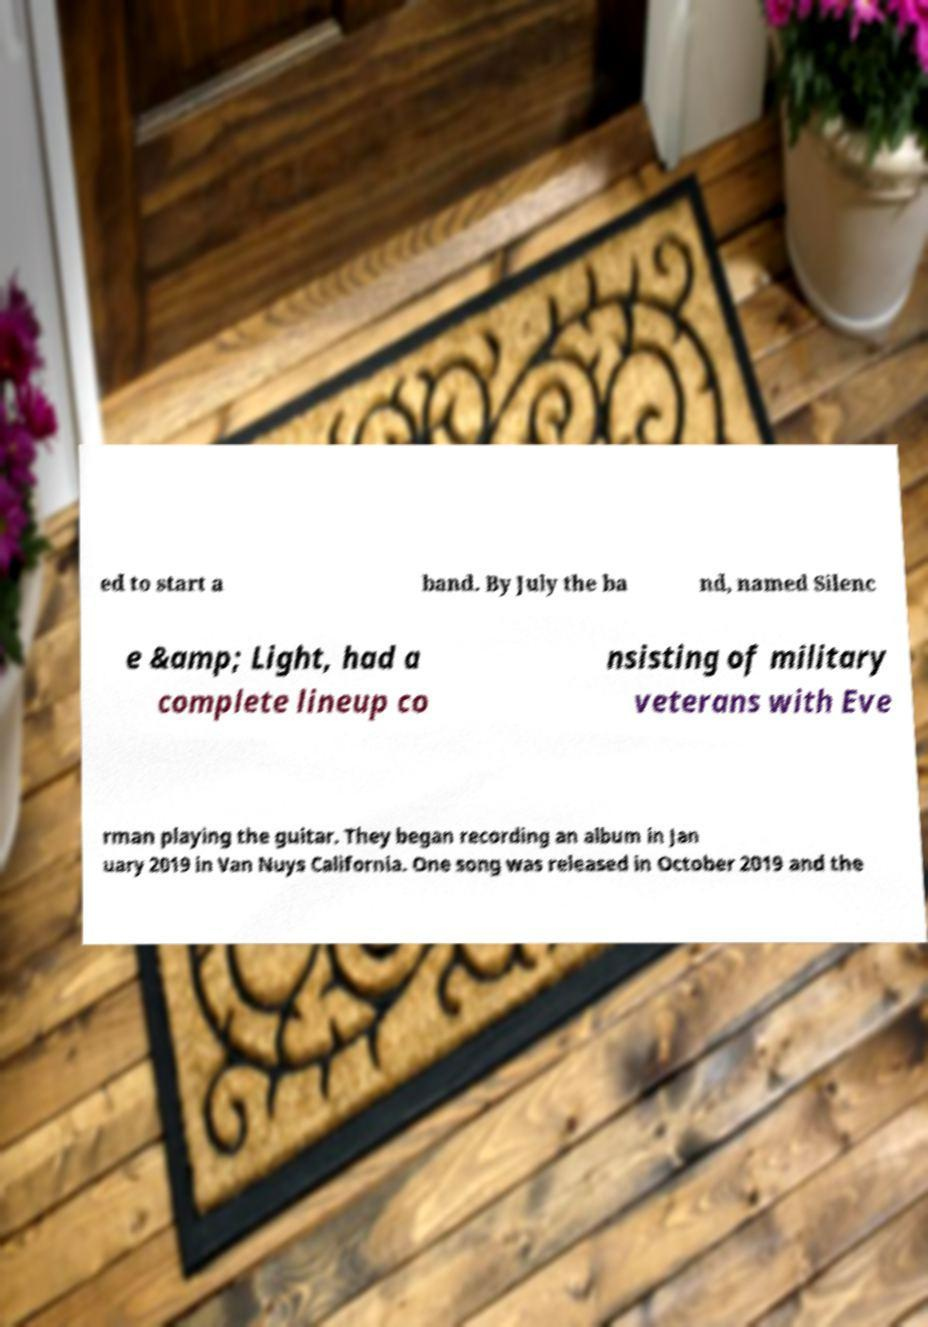Please identify and transcribe the text found in this image. ed to start a band. By July the ba nd, named Silenc e &amp; Light, had a complete lineup co nsisting of military veterans with Eve rman playing the guitar. They began recording an album in Jan uary 2019 in Van Nuys California. One song was released in October 2019 and the 